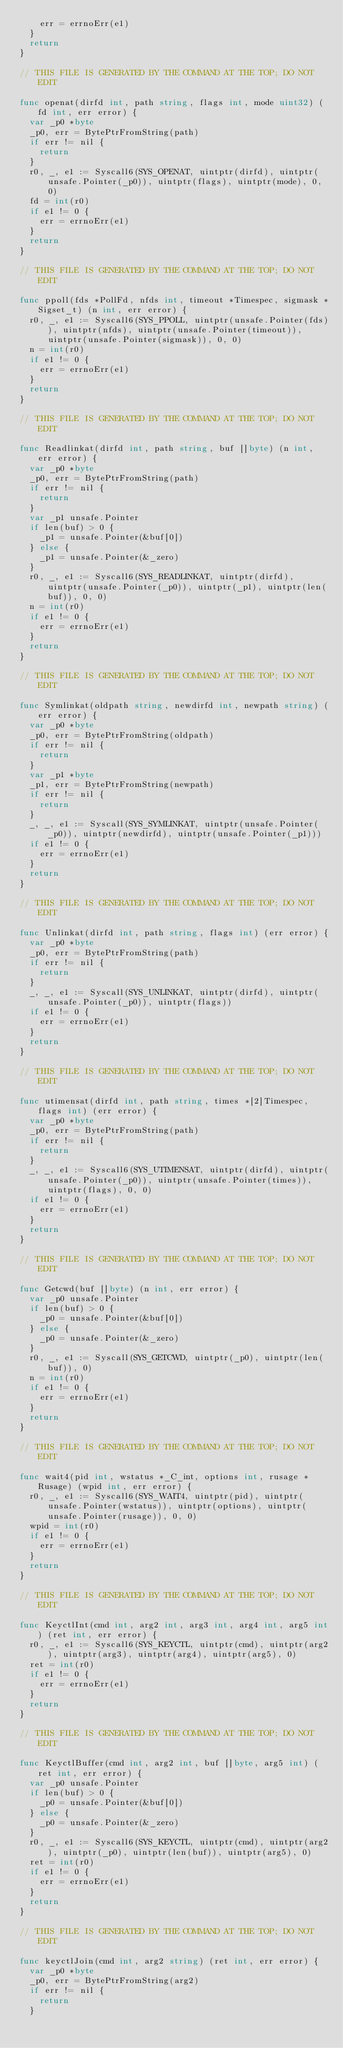<code> <loc_0><loc_0><loc_500><loc_500><_Go_>		err = errnoErr(e1)
	}
	return
}

// THIS FILE IS GENERATED BY THE COMMAND AT THE TOP; DO NOT EDIT

func openat(dirfd int, path string, flags int, mode uint32) (fd int, err error) {
	var _p0 *byte
	_p0, err = BytePtrFromString(path)
	if err != nil {
		return
	}
	r0, _, e1 := Syscall6(SYS_OPENAT, uintptr(dirfd), uintptr(unsafe.Pointer(_p0)), uintptr(flags), uintptr(mode), 0, 0)
	fd = int(r0)
	if e1 != 0 {
		err = errnoErr(e1)
	}
	return
}

// THIS FILE IS GENERATED BY THE COMMAND AT THE TOP; DO NOT EDIT

func ppoll(fds *PollFd, nfds int, timeout *Timespec, sigmask *Sigset_t) (n int, err error) {
	r0, _, e1 := Syscall6(SYS_PPOLL, uintptr(unsafe.Pointer(fds)), uintptr(nfds), uintptr(unsafe.Pointer(timeout)), uintptr(unsafe.Pointer(sigmask)), 0, 0)
	n = int(r0)
	if e1 != 0 {
		err = errnoErr(e1)
	}
	return
}

// THIS FILE IS GENERATED BY THE COMMAND AT THE TOP; DO NOT EDIT

func Readlinkat(dirfd int, path string, buf []byte) (n int, err error) {
	var _p0 *byte
	_p0, err = BytePtrFromString(path)
	if err != nil {
		return
	}
	var _p1 unsafe.Pointer
	if len(buf) > 0 {
		_p1 = unsafe.Pointer(&buf[0])
	} else {
		_p1 = unsafe.Pointer(&_zero)
	}
	r0, _, e1 := Syscall6(SYS_READLINKAT, uintptr(dirfd), uintptr(unsafe.Pointer(_p0)), uintptr(_p1), uintptr(len(buf)), 0, 0)
	n = int(r0)
	if e1 != 0 {
		err = errnoErr(e1)
	}
	return
}

// THIS FILE IS GENERATED BY THE COMMAND AT THE TOP; DO NOT EDIT

func Symlinkat(oldpath string, newdirfd int, newpath string) (err error) {
	var _p0 *byte
	_p0, err = BytePtrFromString(oldpath)
	if err != nil {
		return
	}
	var _p1 *byte
	_p1, err = BytePtrFromString(newpath)
	if err != nil {
		return
	}
	_, _, e1 := Syscall(SYS_SYMLINKAT, uintptr(unsafe.Pointer(_p0)), uintptr(newdirfd), uintptr(unsafe.Pointer(_p1)))
	if e1 != 0 {
		err = errnoErr(e1)
	}
	return
}

// THIS FILE IS GENERATED BY THE COMMAND AT THE TOP; DO NOT EDIT

func Unlinkat(dirfd int, path string, flags int) (err error) {
	var _p0 *byte
	_p0, err = BytePtrFromString(path)
	if err != nil {
		return
	}
	_, _, e1 := Syscall(SYS_UNLINKAT, uintptr(dirfd), uintptr(unsafe.Pointer(_p0)), uintptr(flags))
	if e1 != 0 {
		err = errnoErr(e1)
	}
	return
}

// THIS FILE IS GENERATED BY THE COMMAND AT THE TOP; DO NOT EDIT

func utimensat(dirfd int, path string, times *[2]Timespec, flags int) (err error) {
	var _p0 *byte
	_p0, err = BytePtrFromString(path)
	if err != nil {
		return
	}
	_, _, e1 := Syscall6(SYS_UTIMENSAT, uintptr(dirfd), uintptr(unsafe.Pointer(_p0)), uintptr(unsafe.Pointer(times)), uintptr(flags), 0, 0)
	if e1 != 0 {
		err = errnoErr(e1)
	}
	return
}

// THIS FILE IS GENERATED BY THE COMMAND AT THE TOP; DO NOT EDIT

func Getcwd(buf []byte) (n int, err error) {
	var _p0 unsafe.Pointer
	if len(buf) > 0 {
		_p0 = unsafe.Pointer(&buf[0])
	} else {
		_p0 = unsafe.Pointer(&_zero)
	}
	r0, _, e1 := Syscall(SYS_GETCWD, uintptr(_p0), uintptr(len(buf)), 0)
	n = int(r0)
	if e1 != 0 {
		err = errnoErr(e1)
	}
	return
}

// THIS FILE IS GENERATED BY THE COMMAND AT THE TOP; DO NOT EDIT

func wait4(pid int, wstatus *_C_int, options int, rusage *Rusage) (wpid int, err error) {
	r0, _, e1 := Syscall6(SYS_WAIT4, uintptr(pid), uintptr(unsafe.Pointer(wstatus)), uintptr(options), uintptr(unsafe.Pointer(rusage)), 0, 0)
	wpid = int(r0)
	if e1 != 0 {
		err = errnoErr(e1)
	}
	return
}

// THIS FILE IS GENERATED BY THE COMMAND AT THE TOP; DO NOT EDIT

func KeyctlInt(cmd int, arg2 int, arg3 int, arg4 int, arg5 int) (ret int, err error) {
	r0, _, e1 := Syscall6(SYS_KEYCTL, uintptr(cmd), uintptr(arg2), uintptr(arg3), uintptr(arg4), uintptr(arg5), 0)
	ret = int(r0)
	if e1 != 0 {
		err = errnoErr(e1)
	}
	return
}

// THIS FILE IS GENERATED BY THE COMMAND AT THE TOP; DO NOT EDIT

func KeyctlBuffer(cmd int, arg2 int, buf []byte, arg5 int) (ret int, err error) {
	var _p0 unsafe.Pointer
	if len(buf) > 0 {
		_p0 = unsafe.Pointer(&buf[0])
	} else {
		_p0 = unsafe.Pointer(&_zero)
	}
	r0, _, e1 := Syscall6(SYS_KEYCTL, uintptr(cmd), uintptr(arg2), uintptr(_p0), uintptr(len(buf)), uintptr(arg5), 0)
	ret = int(r0)
	if e1 != 0 {
		err = errnoErr(e1)
	}
	return
}

// THIS FILE IS GENERATED BY THE COMMAND AT THE TOP; DO NOT EDIT

func keyctlJoin(cmd int, arg2 string) (ret int, err error) {
	var _p0 *byte
	_p0, err = BytePtrFromString(arg2)
	if err != nil {
		return
	}</code> 